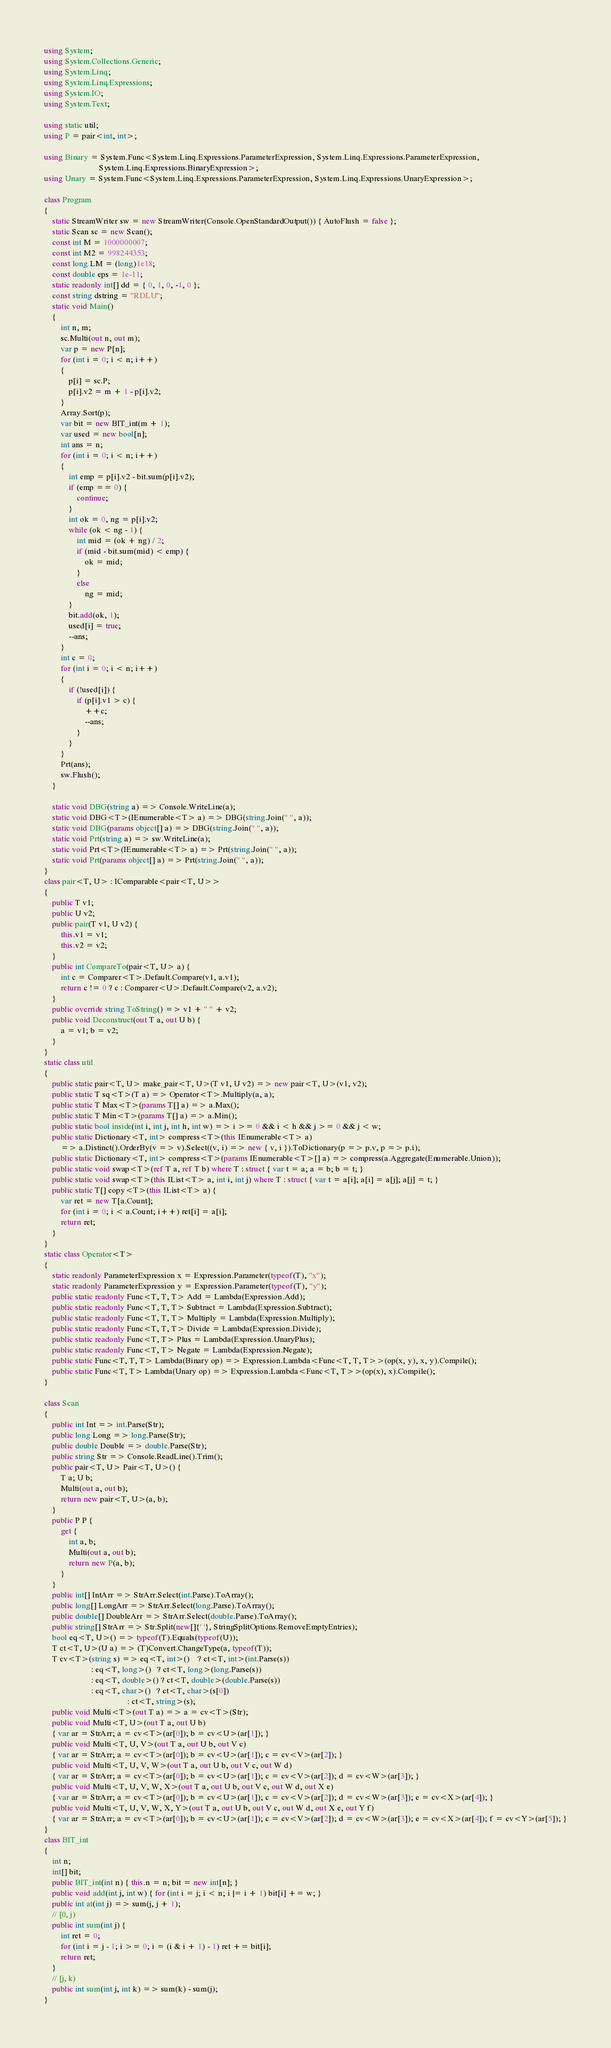<code> <loc_0><loc_0><loc_500><loc_500><_C#_>using System;
using System.Collections.Generic;
using System.Linq;
using System.Linq.Expressions;
using System.IO;
using System.Text;

using static util;
using P = pair<int, int>;

using Binary = System.Func<System.Linq.Expressions.ParameterExpression, System.Linq.Expressions.ParameterExpression,
                           System.Linq.Expressions.BinaryExpression>;
using Unary = System.Func<System.Linq.Expressions.ParameterExpression, System.Linq.Expressions.UnaryExpression>;

class Program
{
    static StreamWriter sw = new StreamWriter(Console.OpenStandardOutput()) { AutoFlush = false };
    static Scan sc = new Scan();
    const int M = 1000000007;
    const int M2 = 998244353;
    const long LM = (long)1e18;
    const double eps = 1e-11;
    static readonly int[] dd = { 0, 1, 0, -1, 0 };
    const string dstring = "RDLU";
    static void Main()
    {
        int n, m;
        sc.Multi(out n, out m);
        var p = new P[n];
        for (int i = 0; i < n; i++)
        {
            p[i] = sc.P;
            p[i].v2 = m + 1 - p[i].v2;
        }
        Array.Sort(p);
        var bit = new BIT_int(m + 1);
        var used = new bool[n];
        int ans = n;
        for (int i = 0; i < n; i++)
        {
            int emp = p[i].v2 - bit.sum(p[i].v2);
            if (emp == 0) {
                continue;
            }
            int ok = 0, ng = p[i].v2;
            while (ok < ng - 1) {
                int mid = (ok + ng) / 2;
                if (mid - bit.sum(mid) < emp) {
                    ok = mid;
                }
                else
                    ng = mid;
            }
            bit.add(ok, 1);
            used[i] = true;
            --ans;
        }
        int c = 0;
        for (int i = 0; i < n; i++)
        {
            if (!used[i]) {
                if (p[i].v1 > c) {
                    ++c;
                    --ans;
                }
            }
        }
        Prt(ans);
        sw.Flush();
    }

    static void DBG(string a) => Console.WriteLine(a);
    static void DBG<T>(IEnumerable<T> a) => DBG(string.Join(" ", a));
    static void DBG(params object[] a) => DBG(string.Join(" ", a));
    static void Prt(string a) => sw.WriteLine(a);
    static void Prt<T>(IEnumerable<T> a) => Prt(string.Join(" ", a));
    static void Prt(params object[] a) => Prt(string.Join(" ", a));
}
class pair<T, U> : IComparable<pair<T, U>>
{
    public T v1;
    public U v2;
    public pair(T v1, U v2) {
        this.v1 = v1;
        this.v2 = v2;
    }
    public int CompareTo(pair<T, U> a) {
        int c = Comparer<T>.Default.Compare(v1, a.v1);
        return c != 0 ? c : Comparer<U>.Default.Compare(v2, a.v2);
    }
    public override string ToString() => v1 + " " + v2;
    public void Deconstruct(out T a, out U b) {
        a = v1; b = v2;
    }
}
static class util
{
    public static pair<T, U> make_pair<T, U>(T v1, U v2) => new pair<T, U>(v1, v2);
    public static T sq<T>(T a) => Operator<T>.Multiply(a, a);
    public static T Max<T>(params T[] a) => a.Max();
    public static T Min<T>(params T[] a) => a.Min();
    public static bool inside(int i, int j, int h, int w) => i >= 0 && i < h && j >= 0 && j < w;
    public static Dictionary<T, int> compress<T>(this IEnumerable<T> a)
        => a.Distinct().OrderBy(v => v).Select((v, i) => new { v, i }).ToDictionary(p => p.v, p => p.i);
    public static Dictionary<T, int> compress<T>(params IEnumerable<T>[] a) => compress(a.Aggregate(Enumerable.Union));
    public static void swap<T>(ref T a, ref T b) where T : struct { var t = a; a = b; b = t; }
    public static void swap<T>(this IList<T> a, int i, int j) where T : struct { var t = a[i]; a[i] = a[j]; a[j] = t; }
    public static T[] copy<T>(this IList<T> a) {
        var ret = new T[a.Count];
        for (int i = 0; i < a.Count; i++) ret[i] = a[i];
        return ret;
    }
}
static class Operator<T>
{
    static readonly ParameterExpression x = Expression.Parameter(typeof(T), "x");
    static readonly ParameterExpression y = Expression.Parameter(typeof(T), "y");
    public static readonly Func<T, T, T> Add = Lambda(Expression.Add);
    public static readonly Func<T, T, T> Subtract = Lambda(Expression.Subtract);
    public static readonly Func<T, T, T> Multiply = Lambda(Expression.Multiply);
    public static readonly Func<T, T, T> Divide = Lambda(Expression.Divide);
    public static readonly Func<T, T> Plus = Lambda(Expression.UnaryPlus);
    public static readonly Func<T, T> Negate = Lambda(Expression.Negate);
    public static Func<T, T, T> Lambda(Binary op) => Expression.Lambda<Func<T, T, T>>(op(x, y), x, y).Compile();
    public static Func<T, T> Lambda(Unary op) => Expression.Lambda<Func<T, T>>(op(x), x).Compile();
}

class Scan
{
    public int Int => int.Parse(Str);
    public long Long => long.Parse(Str);
    public double Double => double.Parse(Str);
    public string Str => Console.ReadLine().Trim();
    public pair<T, U> Pair<T, U>() {
        T a; U b;
        Multi(out a, out b);
        return new pair<T, U>(a, b);
    }
    public P P {
        get {
            int a, b;
            Multi(out a, out b);
            return new P(a, b);
        }
    }
    public int[] IntArr => StrArr.Select(int.Parse).ToArray();
    public long[] LongArr => StrArr.Select(long.Parse).ToArray();
    public double[] DoubleArr => StrArr.Select(double.Parse).ToArray();
    public string[] StrArr => Str.Split(new[]{' '}, StringSplitOptions.RemoveEmptyEntries);
    bool eq<T, U>() => typeof(T).Equals(typeof(U));
    T ct<T, U>(U a) => (T)Convert.ChangeType(a, typeof(T));
    T cv<T>(string s) => eq<T, int>()    ? ct<T, int>(int.Parse(s))
                       : eq<T, long>()   ? ct<T, long>(long.Parse(s))
                       : eq<T, double>() ? ct<T, double>(double.Parse(s))
                       : eq<T, char>()   ? ct<T, char>(s[0])
                                         : ct<T, string>(s);
    public void Multi<T>(out T a) => a = cv<T>(Str);
    public void Multi<T, U>(out T a, out U b)
    { var ar = StrArr; a = cv<T>(ar[0]); b = cv<U>(ar[1]); }
    public void Multi<T, U, V>(out T a, out U b, out V c)
    { var ar = StrArr; a = cv<T>(ar[0]); b = cv<U>(ar[1]); c = cv<V>(ar[2]); }
    public void Multi<T, U, V, W>(out T a, out U b, out V c, out W d)
    { var ar = StrArr; a = cv<T>(ar[0]); b = cv<U>(ar[1]); c = cv<V>(ar[2]); d = cv<W>(ar[3]); }
    public void Multi<T, U, V, W, X>(out T a, out U b, out V c, out W d, out X e)
    { var ar = StrArr; a = cv<T>(ar[0]); b = cv<U>(ar[1]); c = cv<V>(ar[2]); d = cv<W>(ar[3]); e = cv<X>(ar[4]); }
    public void Multi<T, U, V, W, X, Y>(out T a, out U b, out V c, out W d, out X e, out Y f)
    { var ar = StrArr; a = cv<T>(ar[0]); b = cv<U>(ar[1]); c = cv<V>(ar[2]); d = cv<W>(ar[3]); e = cv<X>(ar[4]); f = cv<Y>(ar[5]); }
}
class BIT_int
{
    int n;
    int[] bit;
    public BIT_int(int n) { this.n = n; bit = new int[n]; }
    public void add(int j, int w) { for (int i = j; i < n; i |= i + 1) bit[i] += w; }
    public int at(int j) => sum(j, j + 1);
    // [0, j)
    public int sum(int j) {
        int ret = 0;
        for (int i = j - 1; i >= 0; i = (i & i + 1) - 1) ret += bit[i];
        return ret;
    }
    // [j, k)
    public int sum(int j, int k) => sum(k) - sum(j);
}
</code> 